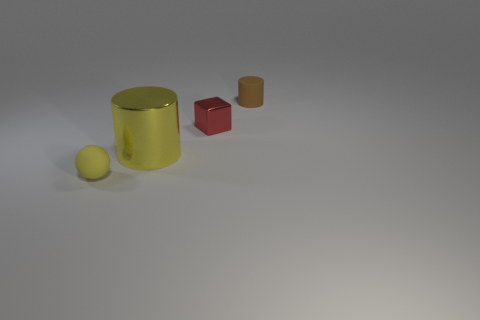What material is the big cylinder that is the same color as the rubber ball?
Offer a very short reply. Metal. How many rubber balls are to the right of the small red metal cube?
Ensure brevity in your answer.  0. What color is the small rubber object that is the same shape as the large yellow thing?
Ensure brevity in your answer.  Brown. There is a tiny object that is in front of the small brown rubber thing and behind the yellow rubber sphere; what is its material?
Make the answer very short. Metal. There is a thing that is behind the block; does it have the same size as the ball?
Provide a succinct answer. Yes. What is the material of the small yellow ball?
Ensure brevity in your answer.  Rubber. What color is the tiny matte object that is behind the small red cube?
Your answer should be compact. Brown. What number of small objects are either gray shiny objects or brown rubber objects?
Offer a terse response. 1. There is a cylinder that is behind the large thing; is its color the same as the cylinder that is in front of the brown rubber cylinder?
Your answer should be very brief. No. What number of other things are there of the same color as the tiny cylinder?
Keep it short and to the point. 0. 